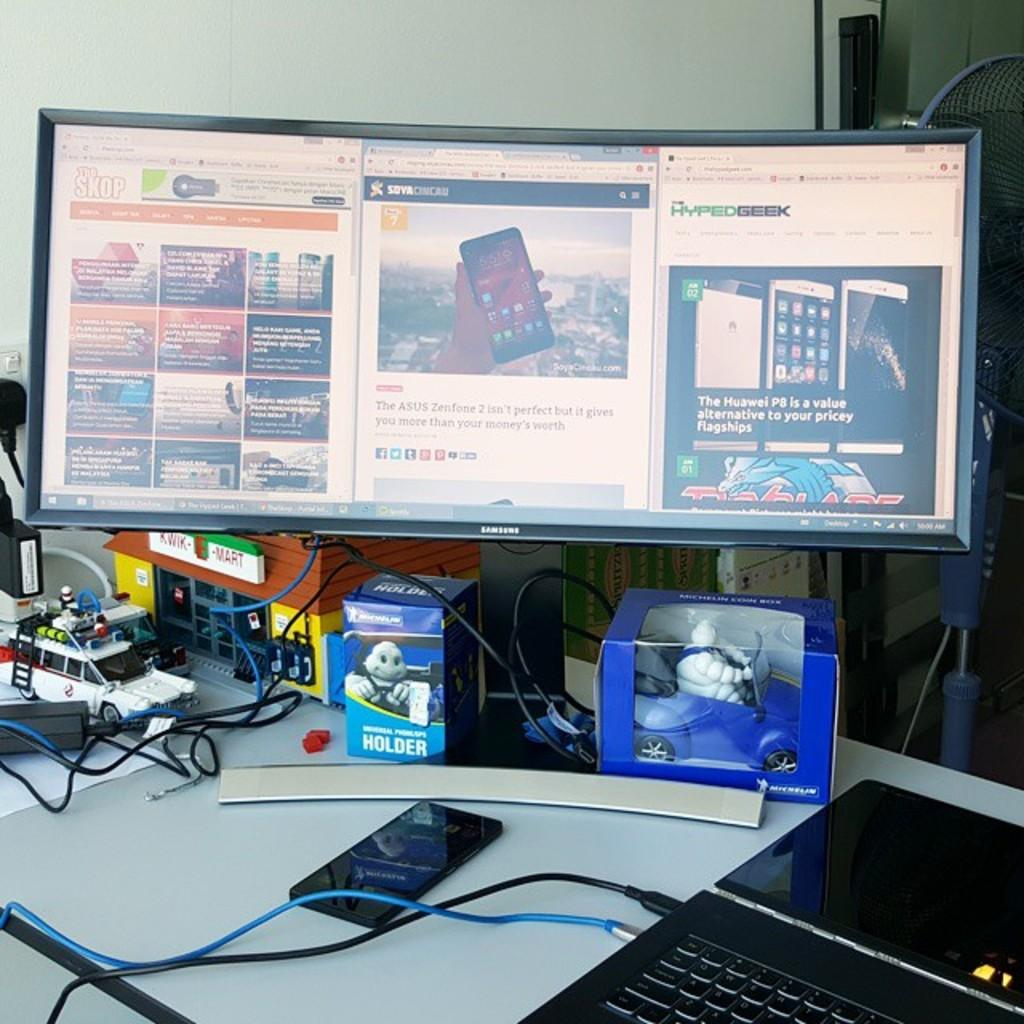<image>
Relay a brief, clear account of the picture shown. a box that says holder on it that has a screen above it 